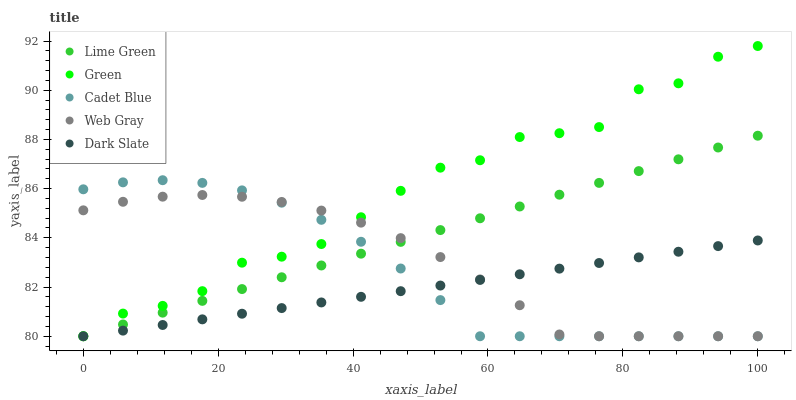Does Dark Slate have the minimum area under the curve?
Answer yes or no. Yes. Does Green have the maximum area under the curve?
Answer yes or no. Yes. Does Cadet Blue have the minimum area under the curve?
Answer yes or no. No. Does Cadet Blue have the maximum area under the curve?
Answer yes or no. No. Is Lime Green the smoothest?
Answer yes or no. Yes. Is Green the roughest?
Answer yes or no. Yes. Is Cadet Blue the smoothest?
Answer yes or no. No. Is Cadet Blue the roughest?
Answer yes or no. No. Does Web Gray have the lowest value?
Answer yes or no. Yes. Does Green have the highest value?
Answer yes or no. Yes. Does Cadet Blue have the highest value?
Answer yes or no. No. Does Lime Green intersect Green?
Answer yes or no. Yes. Is Lime Green less than Green?
Answer yes or no. No. Is Lime Green greater than Green?
Answer yes or no. No. 